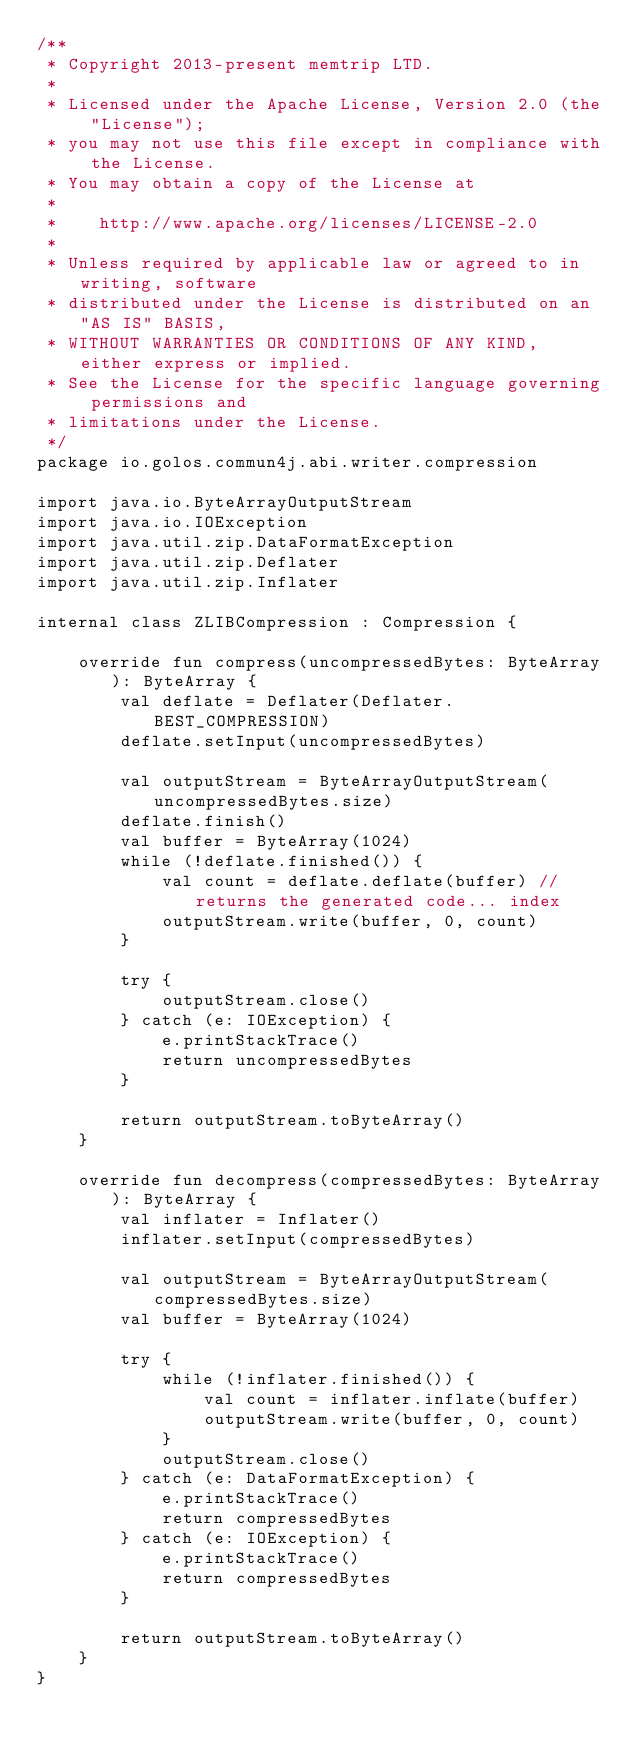<code> <loc_0><loc_0><loc_500><loc_500><_Kotlin_>/**
 * Copyright 2013-present memtrip LTD.
 *
 * Licensed under the Apache License, Version 2.0 (the "License");
 * you may not use this file except in compliance with the License.
 * You may obtain a copy of the License at
 *
 *    http://www.apache.org/licenses/LICENSE-2.0
 *
 * Unless required by applicable law or agreed to in writing, software
 * distributed under the License is distributed on an "AS IS" BASIS,
 * WITHOUT WARRANTIES OR CONDITIONS OF ANY KIND, either express or implied.
 * See the License for the specific language governing permissions and
 * limitations under the License.
 */
package io.golos.commun4j.abi.writer.compression

import java.io.ByteArrayOutputStream
import java.io.IOException
import java.util.zip.DataFormatException
import java.util.zip.Deflater
import java.util.zip.Inflater

internal class ZLIBCompression : Compression {

    override fun compress(uncompressedBytes: ByteArray): ByteArray {
        val deflate = Deflater(Deflater.BEST_COMPRESSION)
        deflate.setInput(uncompressedBytes)

        val outputStream = ByteArrayOutputStream(uncompressedBytes.size)
        deflate.finish()
        val buffer = ByteArray(1024)
        while (!deflate.finished()) {
            val count = deflate.deflate(buffer) // returns the generated code... index
            outputStream.write(buffer, 0, count)
        }

        try {
            outputStream.close()
        } catch (e: IOException) {
            e.printStackTrace()
            return uncompressedBytes
        }

        return outputStream.toByteArray()
    }

    override fun decompress(compressedBytes: ByteArray): ByteArray {
        val inflater = Inflater()
        inflater.setInput(compressedBytes)

        val outputStream = ByteArrayOutputStream(compressedBytes.size)
        val buffer = ByteArray(1024)

        try {
            while (!inflater.finished()) {
                val count = inflater.inflate(buffer)
                outputStream.write(buffer, 0, count)
            }
            outputStream.close()
        } catch (e: DataFormatException) {
            e.printStackTrace()
            return compressedBytes
        } catch (e: IOException) {
            e.printStackTrace()
            return compressedBytes
        }

        return outputStream.toByteArray()
    }
}</code> 